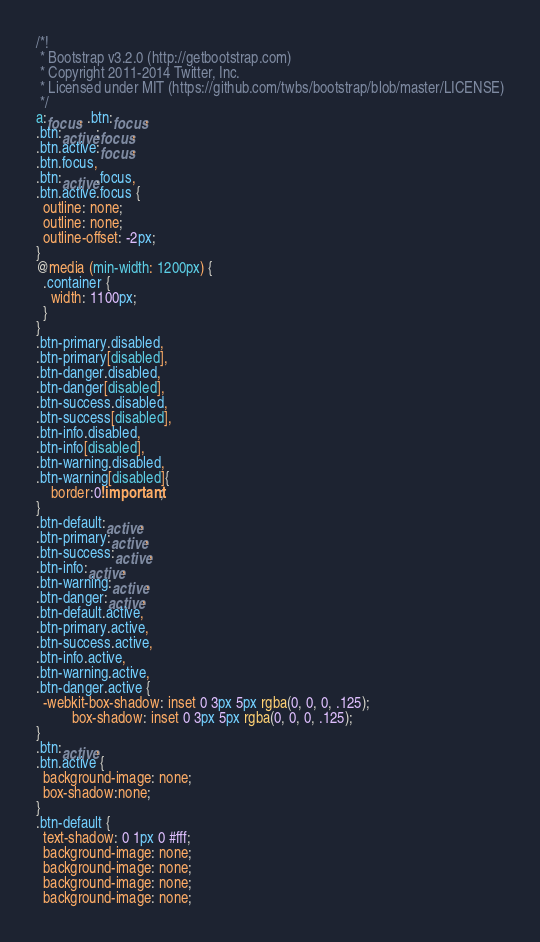Convert code to text. <code><loc_0><loc_0><loc_500><loc_500><_CSS_>/*!
 * Bootstrap v3.2.0 (http://getbootstrap.com)
 * Copyright 2011-2014 Twitter, Inc.
 * Licensed under MIT (https://github.com/twbs/bootstrap/blob/master/LICENSE)
 */
a:focus, .btn:focus,
.btn:active:focus,
.btn.active:focus,
.btn.focus,
.btn:active.focus,
.btn.active.focus {
  outline: none;
  outline: none;
  outline-offset: -2px;
}
@media (min-width: 1200px) {
  .container {
    width: 1100px;
  }
}
.btn-primary.disabled,
.btn-primary[disabled],
.btn-danger.disabled,
.btn-danger[disabled],
.btn-success.disabled,
.btn-success[disabled],
.btn-info.disabled,
.btn-info[disabled],
.btn-warning.disabled,
.btn-warning[disabled]{
	border:0!important;
}
.btn-default:active,
.btn-primary:active,
.btn-success:active,
.btn-info:active,
.btn-warning:active,
.btn-danger:active,
.btn-default.active,
.btn-primary.active,
.btn-success.active,
.btn-info.active,
.btn-warning.active,
.btn-danger.active {
  -webkit-box-shadow: inset 0 3px 5px rgba(0, 0, 0, .125);
          box-shadow: inset 0 3px 5px rgba(0, 0, 0, .125);
}
.btn:active,
.btn.active {
  background-image: none;
  box-shadow:none;
}
.btn-default {
  text-shadow: 0 1px 0 #fff;
  background-image: none;
  background-image: none;
  background-image: none;
  background-image: none;</code> 